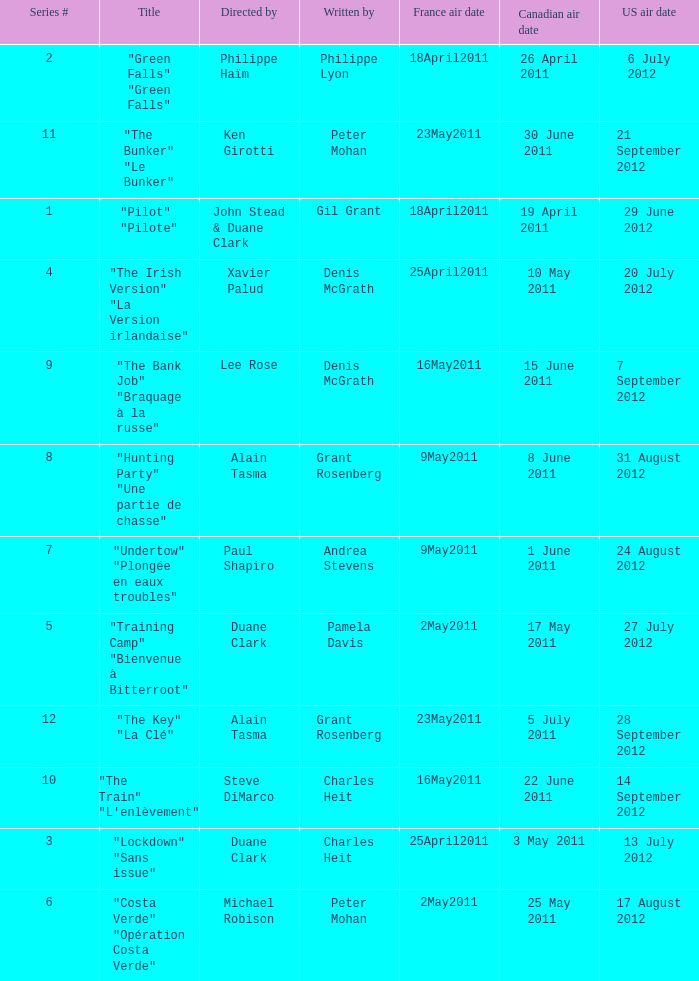What is the US air date when the director is ken girotti? 21 September 2012. 